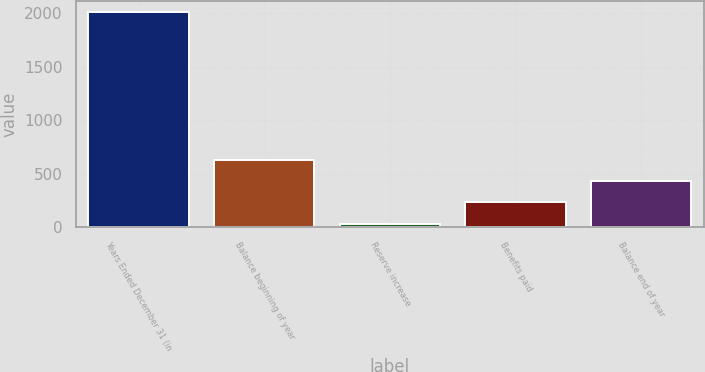Convert chart to OTSL. <chart><loc_0><loc_0><loc_500><loc_500><bar_chart><fcel>Years Ended December 31 (in<fcel>Balance beginning of year<fcel>Reserve increase<fcel>Benefits paid<fcel>Balance end of year<nl><fcel>2013<fcel>626.3<fcel>32<fcel>230.1<fcel>428.2<nl></chart> 